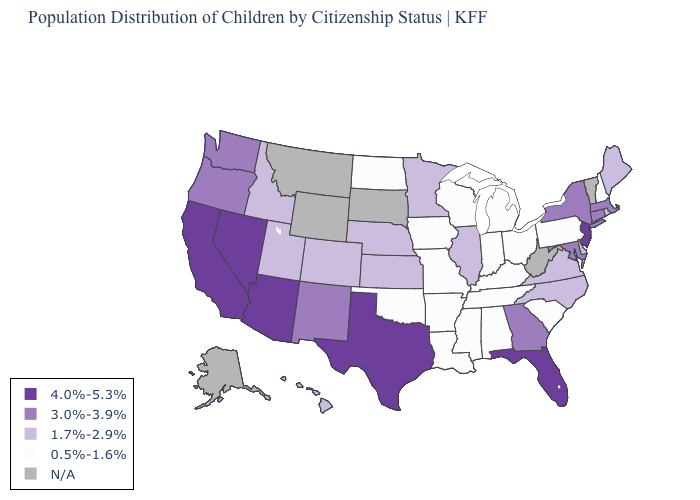Which states hav the highest value in the MidWest?
Give a very brief answer. Illinois, Kansas, Minnesota, Nebraska. What is the value of Arizona?
Short answer required. 4.0%-5.3%. Does the first symbol in the legend represent the smallest category?
Answer briefly. No. Name the states that have a value in the range 4.0%-5.3%?
Quick response, please. Arizona, California, Florida, Nevada, New Jersey, Texas. Which states have the highest value in the USA?
Concise answer only. Arizona, California, Florida, Nevada, New Jersey, Texas. Name the states that have a value in the range 3.0%-3.9%?
Be succinct. Connecticut, Georgia, Maryland, Massachusetts, New Mexico, New York, Oregon, Washington. Name the states that have a value in the range N/A?
Be succinct. Alaska, Montana, South Dakota, Vermont, West Virginia, Wyoming. What is the value of New Hampshire?
Keep it brief. 0.5%-1.6%. What is the value of Maryland?
Write a very short answer. 3.0%-3.9%. Does Kansas have the highest value in the MidWest?
Be succinct. Yes. Does the map have missing data?
Be succinct. Yes. What is the value of Washington?
Quick response, please. 3.0%-3.9%. Which states have the lowest value in the USA?
Write a very short answer. Alabama, Arkansas, Indiana, Iowa, Kentucky, Louisiana, Michigan, Mississippi, Missouri, New Hampshire, North Dakota, Ohio, Oklahoma, Pennsylvania, South Carolina, Tennessee, Wisconsin. What is the value of Tennessee?
Be succinct. 0.5%-1.6%. 